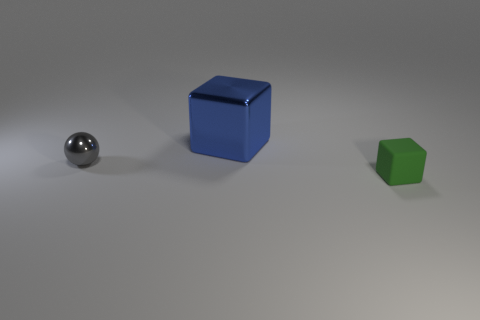There is a block behind the small block; is it the same size as the object right of the blue block?
Your answer should be very brief. No. Is there a tiny matte thing?
Keep it short and to the point. Yes. What size is the metal thing to the right of the small object that is on the left side of the shiny thing right of the gray thing?
Your answer should be very brief. Large. The gray metallic thing that is the same size as the green object is what shape?
Provide a succinct answer. Sphere. Are there any other things that are the same material as the small block?
Your answer should be compact. No. How many things are tiny things that are to the left of the large metallic block or big blue shiny cubes?
Keep it short and to the point. 2. There is a matte cube that is on the right side of the object that is behind the tiny gray ball; is there a small gray shiny thing in front of it?
Provide a succinct answer. No. How many gray rubber objects are there?
Ensure brevity in your answer.  0. What number of objects are tiny objects that are on the right side of the blue cube or blocks that are right of the metal block?
Your response must be concise. 1. There is a metal thing that is behind the metallic ball; is it the same size as the green matte thing?
Provide a succinct answer. No. 